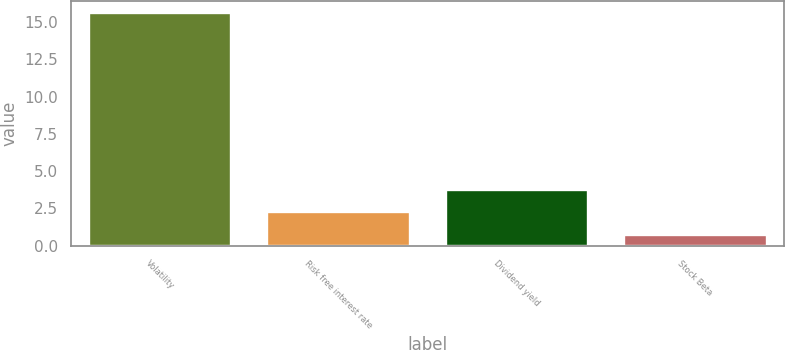Convert chart to OTSL. <chart><loc_0><loc_0><loc_500><loc_500><bar_chart><fcel>Volatility<fcel>Risk free interest rate<fcel>Dividend yield<fcel>Stock Beta<nl><fcel>15.6<fcel>2.23<fcel>3.72<fcel>0.74<nl></chart> 